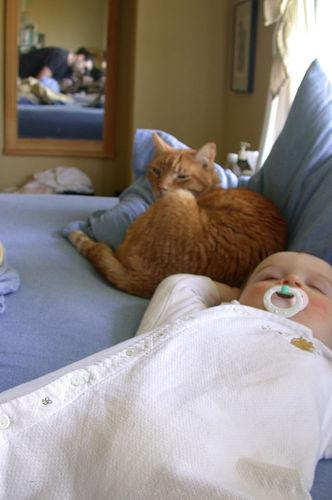Question: who is with the baby?
Choices:
A. A dog.
B. A teddy bear.
C. A cat.
D. A piglet.
Answer with the letter. Answer: C Question: when will the dog get down?
Choices:
A. Soon.
B. No dog.
C. It won't.
D. It already is down.
Answer with the letter. Answer: B Question: what color is the cat?
Choices:
A. Orange.
B. White.
C. Brown.
D. Black.
Answer with the letter. Answer: C Question: what is the man doing?
Choices:
A. Jumping over.
B. Stretching over.
C. Leaning over.
D. Bending over.
Answer with the letter. Answer: C 